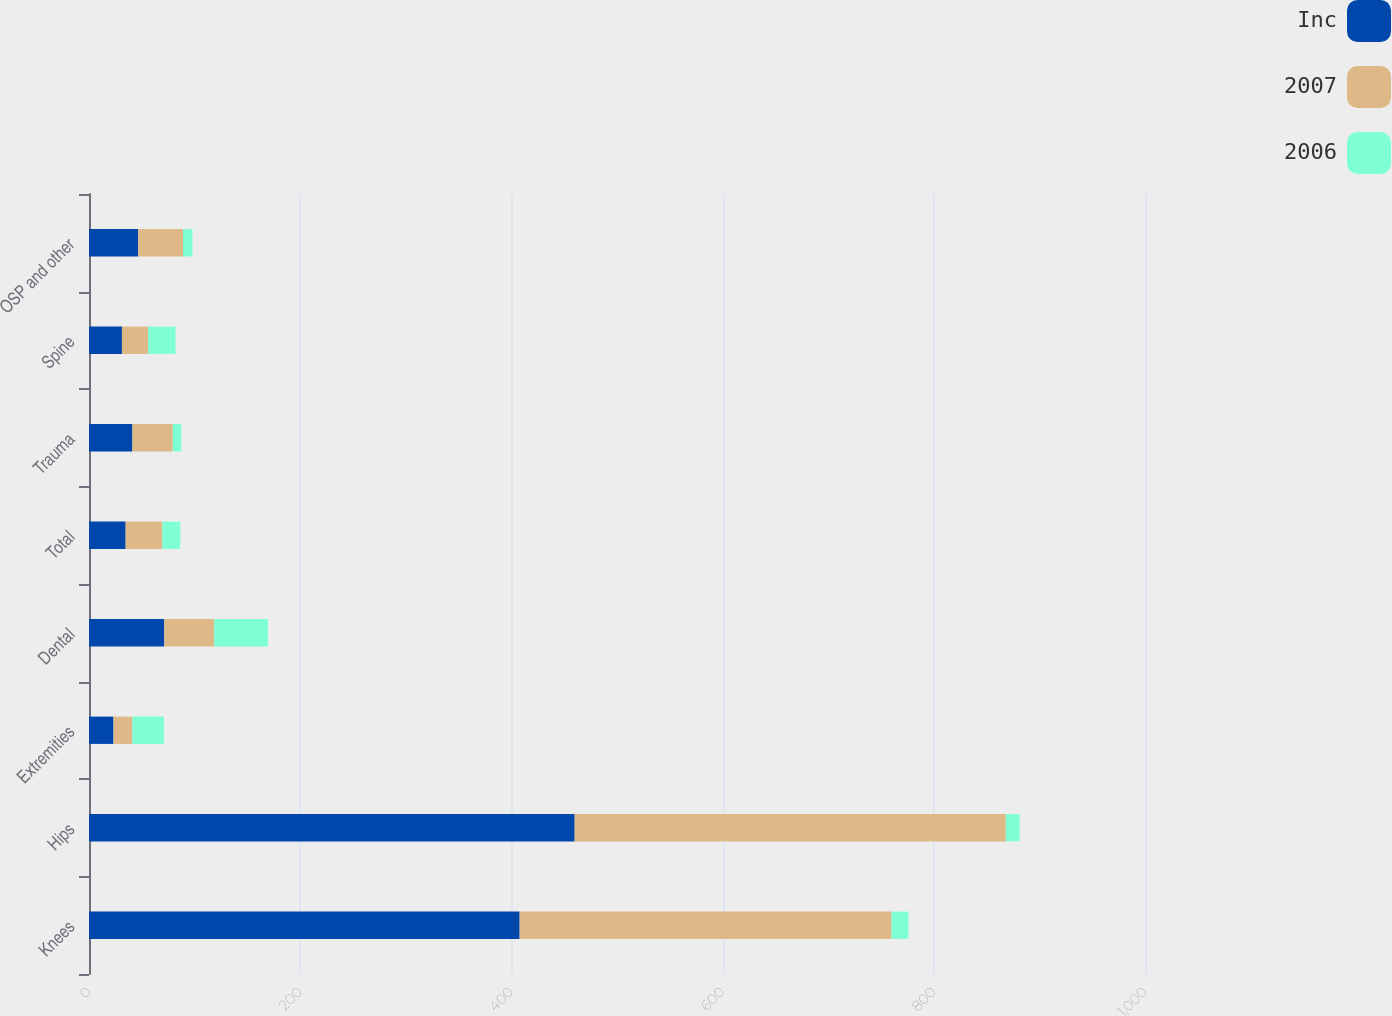Convert chart. <chart><loc_0><loc_0><loc_500><loc_500><stacked_bar_chart><ecel><fcel>Knees<fcel>Hips<fcel>Extremities<fcel>Dental<fcel>Total<fcel>Trauma<fcel>Spine<fcel>OSP and other<nl><fcel>Inc<fcel>407.8<fcel>459.9<fcel>23.2<fcel>71.3<fcel>34.7<fcel>41.1<fcel>31.2<fcel>46.5<nl><fcel>2007<fcel>352.2<fcel>408.3<fcel>17.9<fcel>47.2<fcel>34.7<fcel>38.2<fcel>24.8<fcel>42.5<nl><fcel>2006<fcel>16<fcel>13<fcel>30<fcel>51<fcel>17<fcel>8<fcel>26<fcel>9<nl></chart> 